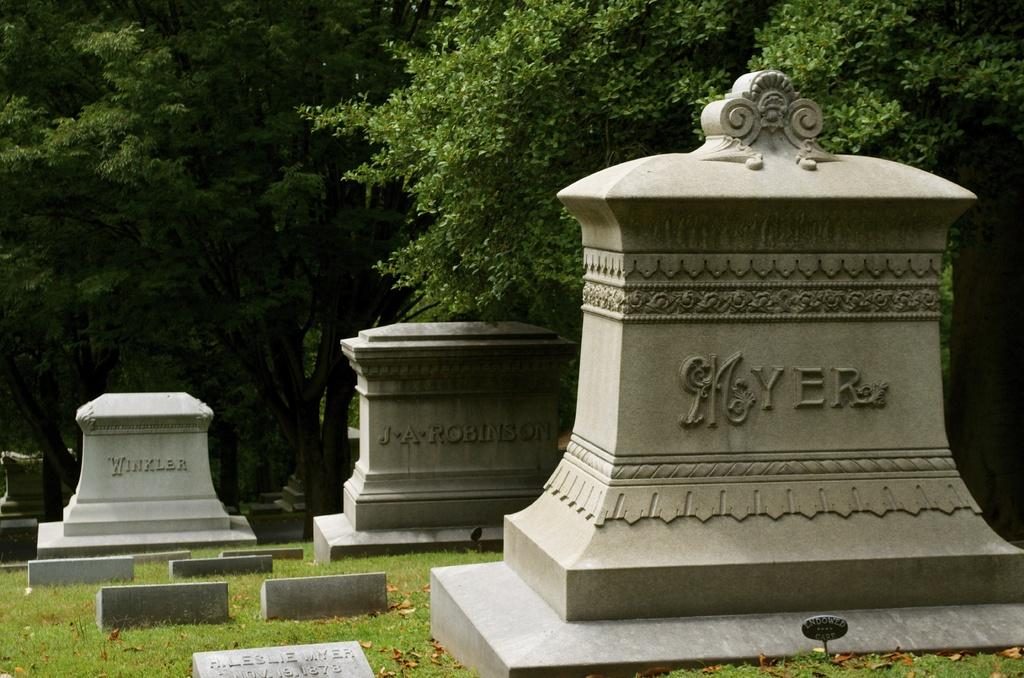What can be seen in the foreground of the image? There are headstones in the foreground of the image. What is visible in the background of the image? There are trees in the background of the image. How many boys are flying planes in the image? There are no boys or planes present in the image. What day of the week is depicted in the image? The image does not depict a specific day of the week. 